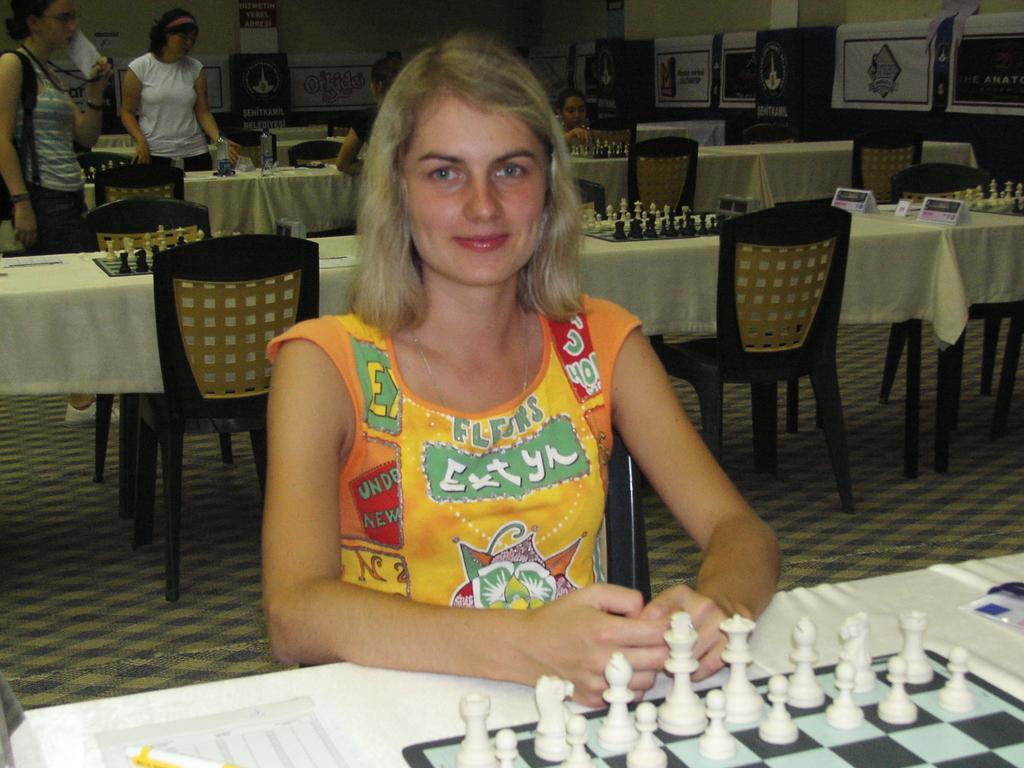Could you give a brief overview of what you see in this image? There is a group of people. In the center person is sitting on a chair. She is smiling. On the left side two persons are standing. One persons is holding a paper and wearing a bag. On the right two persons are sitting on a chair. There is a table. There is a chess board,name board ,pen on a table. We can see in background posters and wall. 